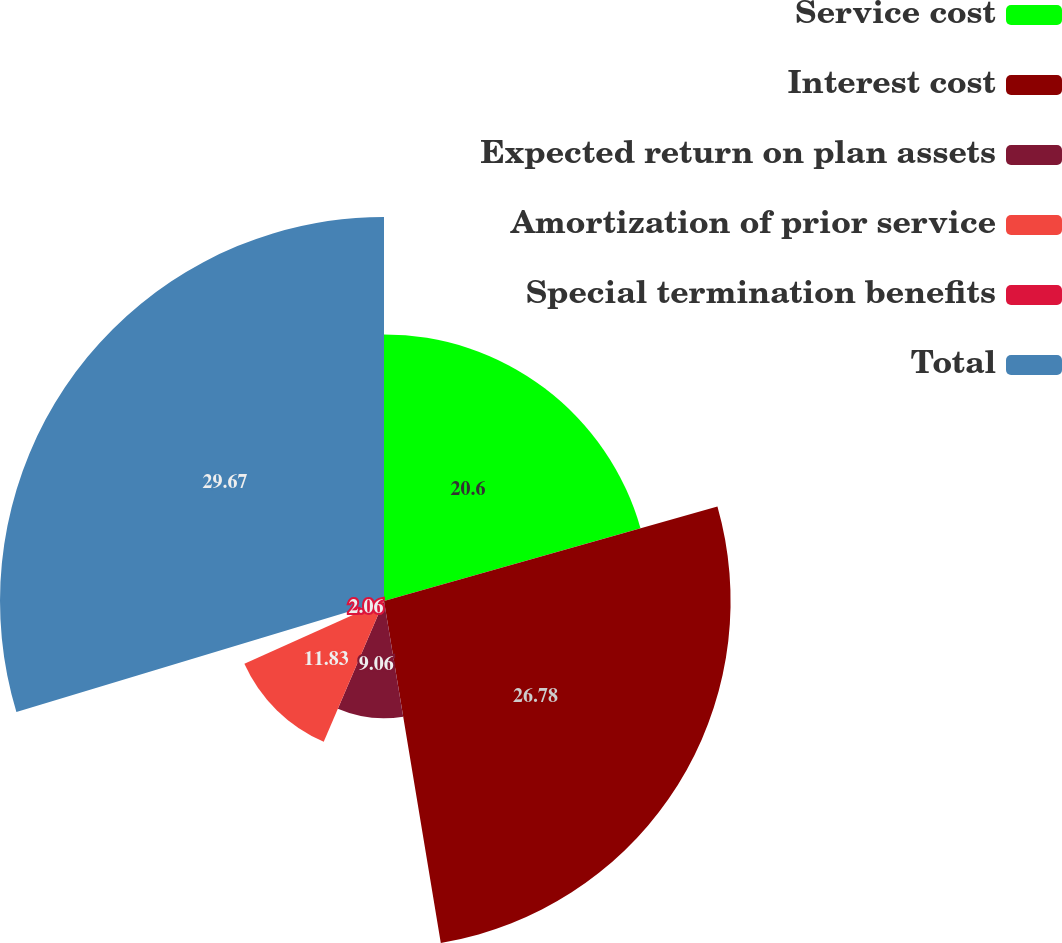Convert chart to OTSL. <chart><loc_0><loc_0><loc_500><loc_500><pie_chart><fcel>Service cost<fcel>Interest cost<fcel>Expected return on plan assets<fcel>Amortization of prior service<fcel>Special termination benefits<fcel>Total<nl><fcel>20.6%<fcel>26.78%<fcel>9.06%<fcel>11.83%<fcel>2.06%<fcel>29.67%<nl></chart> 